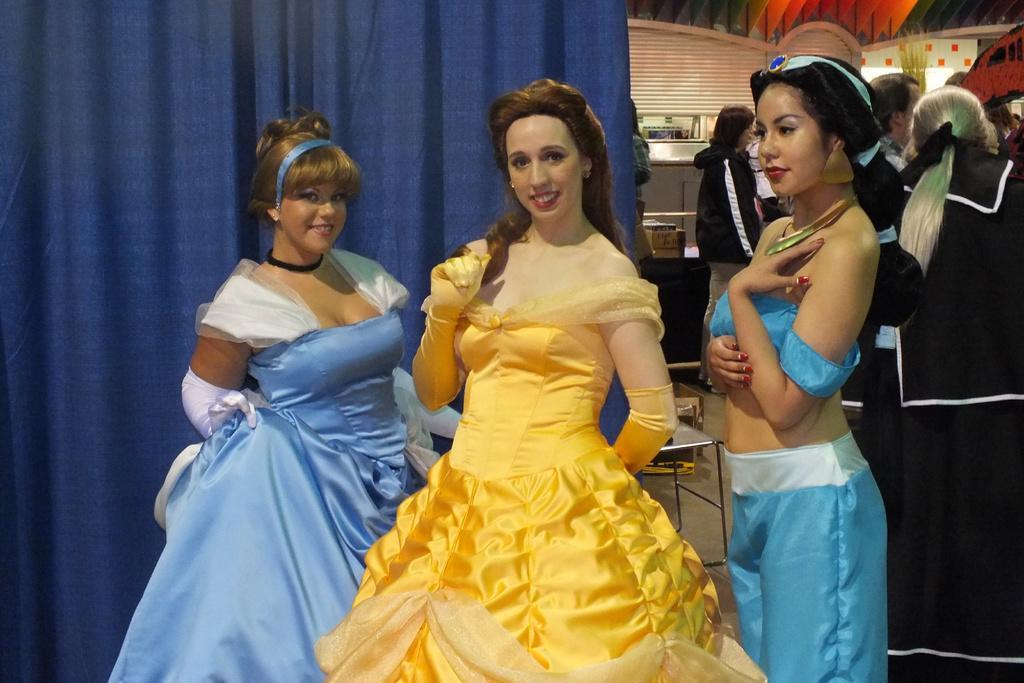Could you give a brief overview of what you see in this image? In this image I can see there are three girls standing on the stage wearing gowns, at the back there is a curtain and another group of people standing. 